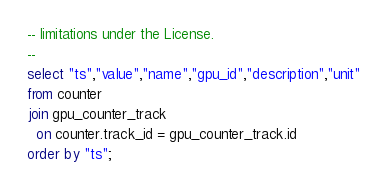Convert code to text. <code><loc_0><loc_0><loc_500><loc_500><_SQL_>-- limitations under the License.
--
select "ts","value","name","gpu_id","description","unit"
from counter
join gpu_counter_track
  on counter.track_id = gpu_counter_track.id
order by "ts";
</code> 